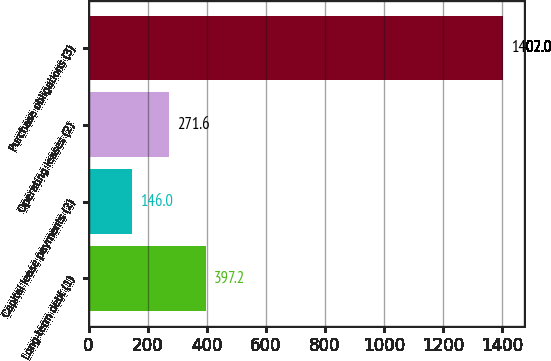Convert chart to OTSL. <chart><loc_0><loc_0><loc_500><loc_500><bar_chart><fcel>Long-term debt (1)<fcel>Capital lease payments (2)<fcel>Operating leases (2)<fcel>Purchase obligations (3)<nl><fcel>397.2<fcel>146<fcel>271.6<fcel>1402<nl></chart> 